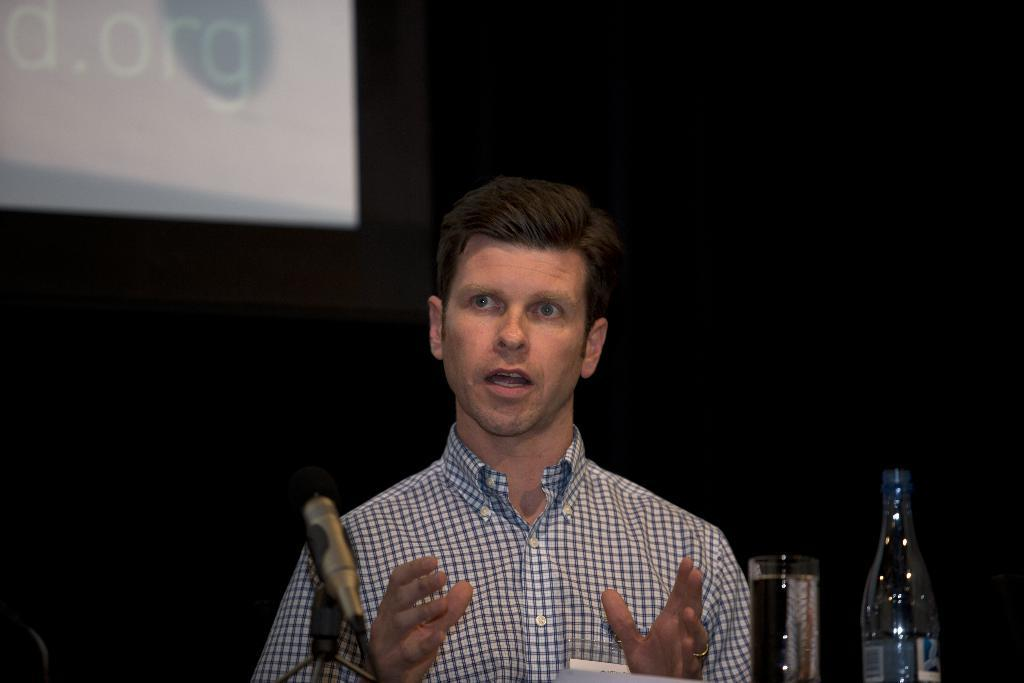Who is the main subject in the image? There is a man in the middle of the image. What object is present that is typically used for amplifying sound? A microphone (mic) is present in the image. What type of container is visible in the image that is commonly used for drinking? There is a glass tumbler in the image. What type of container is visible in the image that is typically used for storing liquids? A disposal bottle is visible in the image. What can be seen behind the man in the image? There is a display behind the man. What is the chance of the man exerting force on the microphone in the image? There is no information about the man's actions or intentions in the image, so it is impossible to determine the chance of him exerting force on the microphone. 